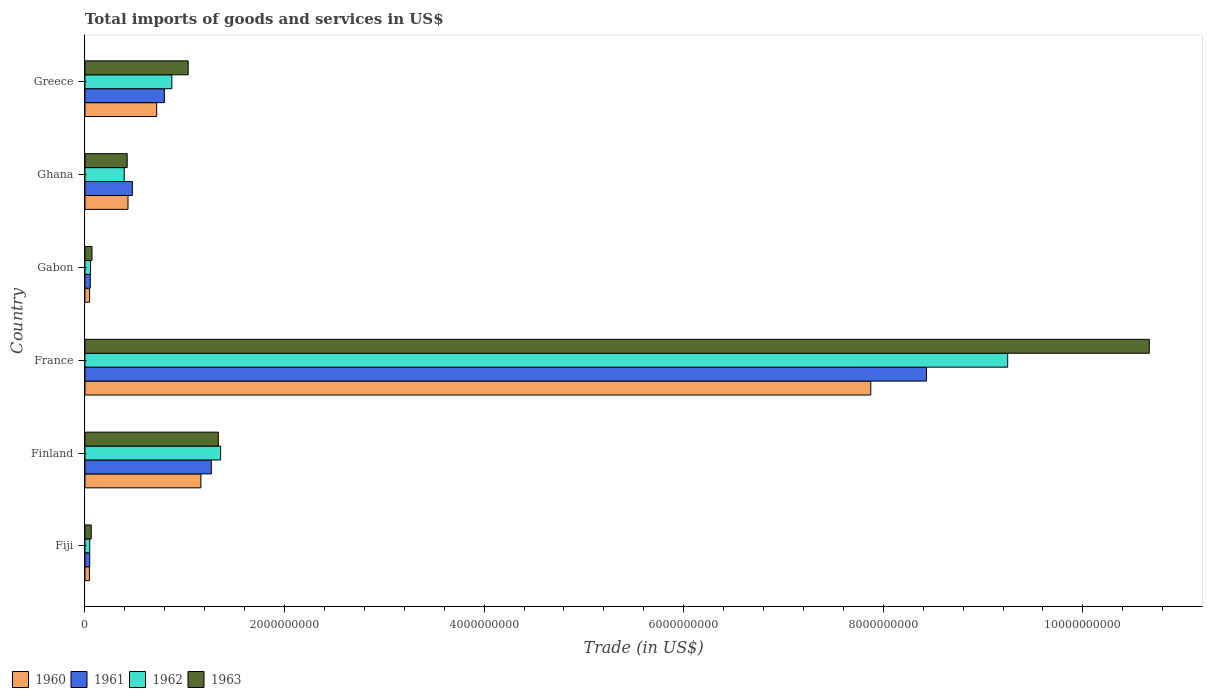How many different coloured bars are there?
Make the answer very short. 4. How many groups of bars are there?
Ensure brevity in your answer.  6. Are the number of bars per tick equal to the number of legend labels?
Your answer should be very brief. Yes. Are the number of bars on each tick of the Y-axis equal?
Offer a very short reply. Yes. How many bars are there on the 4th tick from the top?
Your answer should be compact. 4. What is the label of the 1st group of bars from the top?
Offer a very short reply. Greece. In how many cases, is the number of bars for a given country not equal to the number of legend labels?
Keep it short and to the point. 0. What is the total imports of goods and services in 1963 in Finland?
Provide a succinct answer. 1.34e+09. Across all countries, what is the maximum total imports of goods and services in 1963?
Offer a very short reply. 1.07e+1. Across all countries, what is the minimum total imports of goods and services in 1962?
Your response must be concise. 4.77e+07. In which country was the total imports of goods and services in 1962 minimum?
Provide a succinct answer. Fiji. What is the total total imports of goods and services in 1963 in the graph?
Provide a short and direct response. 1.36e+1. What is the difference between the total imports of goods and services in 1962 in Finland and that in Ghana?
Provide a succinct answer. 9.66e+08. What is the difference between the total imports of goods and services in 1962 in France and the total imports of goods and services in 1963 in Gabon?
Your answer should be compact. 9.18e+09. What is the average total imports of goods and services in 1961 per country?
Keep it short and to the point. 1.85e+09. What is the difference between the total imports of goods and services in 1961 and total imports of goods and services in 1962 in Finland?
Offer a very short reply. -9.31e+07. In how many countries, is the total imports of goods and services in 1962 greater than 2000000000 US$?
Your answer should be very brief. 1. What is the ratio of the total imports of goods and services in 1960 in Finland to that in Gabon?
Your response must be concise. 25.17. What is the difference between the highest and the second highest total imports of goods and services in 1960?
Provide a short and direct response. 6.71e+09. What is the difference between the highest and the lowest total imports of goods and services in 1961?
Your response must be concise. 8.39e+09. What does the 2nd bar from the top in Ghana represents?
Offer a terse response. 1962. Is it the case that in every country, the sum of the total imports of goods and services in 1962 and total imports of goods and services in 1963 is greater than the total imports of goods and services in 1960?
Ensure brevity in your answer.  Yes. Are all the bars in the graph horizontal?
Your answer should be compact. Yes. How many countries are there in the graph?
Provide a short and direct response. 6. What is the difference between two consecutive major ticks on the X-axis?
Your answer should be compact. 2.00e+09. Does the graph contain any zero values?
Provide a succinct answer. No. Does the graph contain grids?
Ensure brevity in your answer.  No. How many legend labels are there?
Provide a short and direct response. 4. How are the legend labels stacked?
Provide a succinct answer. Horizontal. What is the title of the graph?
Provide a short and direct response. Total imports of goods and services in US$. What is the label or title of the X-axis?
Give a very brief answer. Trade (in US$). What is the Trade (in US$) in 1960 in Fiji?
Your answer should be compact. 4.48e+07. What is the Trade (in US$) of 1961 in Fiji?
Offer a very short reply. 4.77e+07. What is the Trade (in US$) in 1962 in Fiji?
Your answer should be compact. 4.77e+07. What is the Trade (in US$) in 1963 in Fiji?
Your response must be concise. 6.30e+07. What is the Trade (in US$) of 1960 in Finland?
Ensure brevity in your answer.  1.16e+09. What is the Trade (in US$) of 1961 in Finland?
Provide a succinct answer. 1.27e+09. What is the Trade (in US$) in 1962 in Finland?
Offer a terse response. 1.36e+09. What is the Trade (in US$) in 1963 in Finland?
Provide a short and direct response. 1.34e+09. What is the Trade (in US$) of 1960 in France?
Make the answer very short. 7.87e+09. What is the Trade (in US$) in 1961 in France?
Give a very brief answer. 8.43e+09. What is the Trade (in US$) in 1962 in France?
Your answer should be compact. 9.25e+09. What is the Trade (in US$) of 1963 in France?
Keep it short and to the point. 1.07e+1. What is the Trade (in US$) in 1960 in Gabon?
Offer a very short reply. 4.62e+07. What is the Trade (in US$) in 1961 in Gabon?
Your response must be concise. 5.31e+07. What is the Trade (in US$) in 1962 in Gabon?
Your answer should be compact. 5.62e+07. What is the Trade (in US$) in 1963 in Gabon?
Offer a terse response. 7.01e+07. What is the Trade (in US$) of 1960 in Ghana?
Offer a very short reply. 4.31e+08. What is the Trade (in US$) of 1961 in Ghana?
Your answer should be compact. 4.75e+08. What is the Trade (in US$) of 1962 in Ghana?
Your response must be concise. 3.94e+08. What is the Trade (in US$) in 1963 in Ghana?
Your answer should be very brief. 4.23e+08. What is the Trade (in US$) of 1960 in Greece?
Give a very brief answer. 7.19e+08. What is the Trade (in US$) of 1961 in Greece?
Your answer should be very brief. 7.96e+08. What is the Trade (in US$) in 1962 in Greece?
Ensure brevity in your answer.  8.70e+08. What is the Trade (in US$) in 1963 in Greece?
Provide a short and direct response. 1.03e+09. Across all countries, what is the maximum Trade (in US$) in 1960?
Your answer should be very brief. 7.87e+09. Across all countries, what is the maximum Trade (in US$) in 1961?
Your answer should be very brief. 8.43e+09. Across all countries, what is the maximum Trade (in US$) in 1962?
Give a very brief answer. 9.25e+09. Across all countries, what is the maximum Trade (in US$) in 1963?
Ensure brevity in your answer.  1.07e+1. Across all countries, what is the minimum Trade (in US$) in 1960?
Offer a very short reply. 4.48e+07. Across all countries, what is the minimum Trade (in US$) of 1961?
Your answer should be very brief. 4.77e+07. Across all countries, what is the minimum Trade (in US$) of 1962?
Ensure brevity in your answer.  4.77e+07. Across all countries, what is the minimum Trade (in US$) of 1963?
Give a very brief answer. 6.30e+07. What is the total Trade (in US$) of 1960 in the graph?
Keep it short and to the point. 1.03e+1. What is the total Trade (in US$) of 1961 in the graph?
Offer a very short reply. 1.11e+1. What is the total Trade (in US$) in 1962 in the graph?
Offer a terse response. 1.20e+1. What is the total Trade (in US$) of 1963 in the graph?
Provide a short and direct response. 1.36e+1. What is the difference between the Trade (in US$) of 1960 in Fiji and that in Finland?
Keep it short and to the point. -1.12e+09. What is the difference between the Trade (in US$) in 1961 in Fiji and that in Finland?
Offer a very short reply. -1.22e+09. What is the difference between the Trade (in US$) in 1962 in Fiji and that in Finland?
Make the answer very short. -1.31e+09. What is the difference between the Trade (in US$) in 1963 in Fiji and that in Finland?
Your response must be concise. -1.27e+09. What is the difference between the Trade (in US$) in 1960 in Fiji and that in France?
Make the answer very short. -7.83e+09. What is the difference between the Trade (in US$) in 1961 in Fiji and that in France?
Make the answer very short. -8.39e+09. What is the difference between the Trade (in US$) of 1962 in Fiji and that in France?
Make the answer very short. -9.20e+09. What is the difference between the Trade (in US$) of 1963 in Fiji and that in France?
Ensure brevity in your answer.  -1.06e+1. What is the difference between the Trade (in US$) of 1960 in Fiji and that in Gabon?
Give a very brief answer. -1.32e+06. What is the difference between the Trade (in US$) of 1961 in Fiji and that in Gabon?
Offer a terse response. -5.35e+06. What is the difference between the Trade (in US$) of 1962 in Fiji and that in Gabon?
Give a very brief answer. -8.51e+06. What is the difference between the Trade (in US$) in 1963 in Fiji and that in Gabon?
Keep it short and to the point. -7.16e+06. What is the difference between the Trade (in US$) in 1960 in Fiji and that in Ghana?
Ensure brevity in your answer.  -3.87e+08. What is the difference between the Trade (in US$) of 1961 in Fiji and that in Ghana?
Ensure brevity in your answer.  -4.27e+08. What is the difference between the Trade (in US$) in 1962 in Fiji and that in Ghana?
Your answer should be compact. -3.46e+08. What is the difference between the Trade (in US$) in 1963 in Fiji and that in Ghana?
Make the answer very short. -3.60e+08. What is the difference between the Trade (in US$) of 1960 in Fiji and that in Greece?
Provide a succinct answer. -6.74e+08. What is the difference between the Trade (in US$) of 1961 in Fiji and that in Greece?
Make the answer very short. -7.48e+08. What is the difference between the Trade (in US$) of 1962 in Fiji and that in Greece?
Keep it short and to the point. -8.23e+08. What is the difference between the Trade (in US$) in 1963 in Fiji and that in Greece?
Offer a very short reply. -9.71e+08. What is the difference between the Trade (in US$) in 1960 in Finland and that in France?
Give a very brief answer. -6.71e+09. What is the difference between the Trade (in US$) of 1961 in Finland and that in France?
Your response must be concise. -7.17e+09. What is the difference between the Trade (in US$) of 1962 in Finland and that in France?
Keep it short and to the point. -7.89e+09. What is the difference between the Trade (in US$) of 1963 in Finland and that in France?
Your answer should be very brief. -9.33e+09. What is the difference between the Trade (in US$) in 1960 in Finland and that in Gabon?
Offer a very short reply. 1.12e+09. What is the difference between the Trade (in US$) of 1961 in Finland and that in Gabon?
Ensure brevity in your answer.  1.21e+09. What is the difference between the Trade (in US$) in 1962 in Finland and that in Gabon?
Make the answer very short. 1.30e+09. What is the difference between the Trade (in US$) in 1963 in Finland and that in Gabon?
Ensure brevity in your answer.  1.27e+09. What is the difference between the Trade (in US$) of 1960 in Finland and that in Ghana?
Provide a short and direct response. 7.30e+08. What is the difference between the Trade (in US$) in 1961 in Finland and that in Ghana?
Keep it short and to the point. 7.91e+08. What is the difference between the Trade (in US$) in 1962 in Finland and that in Ghana?
Offer a terse response. 9.66e+08. What is the difference between the Trade (in US$) of 1963 in Finland and that in Ghana?
Your answer should be very brief. 9.13e+08. What is the difference between the Trade (in US$) in 1960 in Finland and that in Greece?
Provide a succinct answer. 4.43e+08. What is the difference between the Trade (in US$) in 1961 in Finland and that in Greece?
Your answer should be compact. 4.70e+08. What is the difference between the Trade (in US$) in 1962 in Finland and that in Greece?
Offer a terse response. 4.89e+08. What is the difference between the Trade (in US$) in 1963 in Finland and that in Greece?
Provide a succinct answer. 3.02e+08. What is the difference between the Trade (in US$) in 1960 in France and that in Gabon?
Keep it short and to the point. 7.83e+09. What is the difference between the Trade (in US$) of 1961 in France and that in Gabon?
Provide a short and direct response. 8.38e+09. What is the difference between the Trade (in US$) in 1962 in France and that in Gabon?
Provide a short and direct response. 9.19e+09. What is the difference between the Trade (in US$) of 1963 in France and that in Gabon?
Your answer should be compact. 1.06e+1. What is the difference between the Trade (in US$) of 1960 in France and that in Ghana?
Give a very brief answer. 7.44e+09. What is the difference between the Trade (in US$) in 1961 in France and that in Ghana?
Offer a very short reply. 7.96e+09. What is the difference between the Trade (in US$) of 1962 in France and that in Ghana?
Keep it short and to the point. 8.85e+09. What is the difference between the Trade (in US$) in 1963 in France and that in Ghana?
Provide a short and direct response. 1.02e+1. What is the difference between the Trade (in US$) in 1960 in France and that in Greece?
Keep it short and to the point. 7.16e+09. What is the difference between the Trade (in US$) of 1961 in France and that in Greece?
Offer a very short reply. 7.64e+09. What is the difference between the Trade (in US$) in 1962 in France and that in Greece?
Ensure brevity in your answer.  8.38e+09. What is the difference between the Trade (in US$) in 1963 in France and that in Greece?
Offer a very short reply. 9.63e+09. What is the difference between the Trade (in US$) in 1960 in Gabon and that in Ghana?
Provide a succinct answer. -3.85e+08. What is the difference between the Trade (in US$) in 1961 in Gabon and that in Ghana?
Your answer should be compact. -4.22e+08. What is the difference between the Trade (in US$) of 1962 in Gabon and that in Ghana?
Make the answer very short. -3.37e+08. What is the difference between the Trade (in US$) in 1963 in Gabon and that in Ghana?
Your answer should be compact. -3.53e+08. What is the difference between the Trade (in US$) of 1960 in Gabon and that in Greece?
Offer a very short reply. -6.72e+08. What is the difference between the Trade (in US$) in 1961 in Gabon and that in Greece?
Give a very brief answer. -7.43e+08. What is the difference between the Trade (in US$) in 1962 in Gabon and that in Greece?
Provide a short and direct response. -8.14e+08. What is the difference between the Trade (in US$) of 1963 in Gabon and that in Greece?
Keep it short and to the point. -9.64e+08. What is the difference between the Trade (in US$) in 1960 in Ghana and that in Greece?
Offer a terse response. -2.87e+08. What is the difference between the Trade (in US$) in 1961 in Ghana and that in Greece?
Keep it short and to the point. -3.21e+08. What is the difference between the Trade (in US$) of 1962 in Ghana and that in Greece?
Your response must be concise. -4.77e+08. What is the difference between the Trade (in US$) in 1963 in Ghana and that in Greece?
Ensure brevity in your answer.  -6.11e+08. What is the difference between the Trade (in US$) of 1960 in Fiji and the Trade (in US$) of 1961 in Finland?
Make the answer very short. -1.22e+09. What is the difference between the Trade (in US$) of 1960 in Fiji and the Trade (in US$) of 1962 in Finland?
Make the answer very short. -1.31e+09. What is the difference between the Trade (in US$) of 1960 in Fiji and the Trade (in US$) of 1963 in Finland?
Provide a short and direct response. -1.29e+09. What is the difference between the Trade (in US$) of 1961 in Fiji and the Trade (in US$) of 1962 in Finland?
Offer a terse response. -1.31e+09. What is the difference between the Trade (in US$) of 1961 in Fiji and the Trade (in US$) of 1963 in Finland?
Make the answer very short. -1.29e+09. What is the difference between the Trade (in US$) in 1962 in Fiji and the Trade (in US$) in 1963 in Finland?
Make the answer very short. -1.29e+09. What is the difference between the Trade (in US$) of 1960 in Fiji and the Trade (in US$) of 1961 in France?
Provide a succinct answer. -8.39e+09. What is the difference between the Trade (in US$) in 1960 in Fiji and the Trade (in US$) in 1962 in France?
Keep it short and to the point. -9.20e+09. What is the difference between the Trade (in US$) in 1960 in Fiji and the Trade (in US$) in 1963 in France?
Offer a terse response. -1.06e+1. What is the difference between the Trade (in US$) in 1961 in Fiji and the Trade (in US$) in 1962 in France?
Ensure brevity in your answer.  -9.20e+09. What is the difference between the Trade (in US$) in 1961 in Fiji and the Trade (in US$) in 1963 in France?
Offer a terse response. -1.06e+1. What is the difference between the Trade (in US$) in 1962 in Fiji and the Trade (in US$) in 1963 in France?
Ensure brevity in your answer.  -1.06e+1. What is the difference between the Trade (in US$) of 1960 in Fiji and the Trade (in US$) of 1961 in Gabon?
Make the answer very short. -8.25e+06. What is the difference between the Trade (in US$) of 1960 in Fiji and the Trade (in US$) of 1962 in Gabon?
Offer a very short reply. -1.14e+07. What is the difference between the Trade (in US$) in 1960 in Fiji and the Trade (in US$) in 1963 in Gabon?
Make the answer very short. -2.53e+07. What is the difference between the Trade (in US$) in 1961 in Fiji and the Trade (in US$) in 1962 in Gabon?
Give a very brief answer. -8.51e+06. What is the difference between the Trade (in US$) of 1961 in Fiji and the Trade (in US$) of 1963 in Gabon?
Your answer should be very brief. -2.24e+07. What is the difference between the Trade (in US$) in 1962 in Fiji and the Trade (in US$) in 1963 in Gabon?
Your response must be concise. -2.24e+07. What is the difference between the Trade (in US$) in 1960 in Fiji and the Trade (in US$) in 1961 in Ghana?
Give a very brief answer. -4.30e+08. What is the difference between the Trade (in US$) in 1960 in Fiji and the Trade (in US$) in 1962 in Ghana?
Your answer should be very brief. -3.49e+08. What is the difference between the Trade (in US$) in 1960 in Fiji and the Trade (in US$) in 1963 in Ghana?
Keep it short and to the point. -3.78e+08. What is the difference between the Trade (in US$) of 1961 in Fiji and the Trade (in US$) of 1962 in Ghana?
Your answer should be very brief. -3.46e+08. What is the difference between the Trade (in US$) of 1961 in Fiji and the Trade (in US$) of 1963 in Ghana?
Keep it short and to the point. -3.75e+08. What is the difference between the Trade (in US$) in 1962 in Fiji and the Trade (in US$) in 1963 in Ghana?
Offer a very short reply. -3.75e+08. What is the difference between the Trade (in US$) of 1960 in Fiji and the Trade (in US$) of 1961 in Greece?
Keep it short and to the point. -7.51e+08. What is the difference between the Trade (in US$) of 1960 in Fiji and the Trade (in US$) of 1962 in Greece?
Give a very brief answer. -8.25e+08. What is the difference between the Trade (in US$) in 1960 in Fiji and the Trade (in US$) in 1963 in Greece?
Keep it short and to the point. -9.89e+08. What is the difference between the Trade (in US$) in 1961 in Fiji and the Trade (in US$) in 1962 in Greece?
Provide a short and direct response. -8.23e+08. What is the difference between the Trade (in US$) of 1961 in Fiji and the Trade (in US$) of 1963 in Greece?
Make the answer very short. -9.86e+08. What is the difference between the Trade (in US$) of 1962 in Fiji and the Trade (in US$) of 1963 in Greece?
Give a very brief answer. -9.86e+08. What is the difference between the Trade (in US$) of 1960 in Finland and the Trade (in US$) of 1961 in France?
Your response must be concise. -7.27e+09. What is the difference between the Trade (in US$) of 1960 in Finland and the Trade (in US$) of 1962 in France?
Keep it short and to the point. -8.08e+09. What is the difference between the Trade (in US$) of 1960 in Finland and the Trade (in US$) of 1963 in France?
Keep it short and to the point. -9.50e+09. What is the difference between the Trade (in US$) in 1961 in Finland and the Trade (in US$) in 1962 in France?
Your response must be concise. -7.98e+09. What is the difference between the Trade (in US$) in 1961 in Finland and the Trade (in US$) in 1963 in France?
Keep it short and to the point. -9.40e+09. What is the difference between the Trade (in US$) of 1962 in Finland and the Trade (in US$) of 1963 in France?
Your answer should be very brief. -9.31e+09. What is the difference between the Trade (in US$) of 1960 in Finland and the Trade (in US$) of 1961 in Gabon?
Keep it short and to the point. 1.11e+09. What is the difference between the Trade (in US$) in 1960 in Finland and the Trade (in US$) in 1962 in Gabon?
Your answer should be compact. 1.11e+09. What is the difference between the Trade (in US$) of 1960 in Finland and the Trade (in US$) of 1963 in Gabon?
Make the answer very short. 1.09e+09. What is the difference between the Trade (in US$) of 1961 in Finland and the Trade (in US$) of 1962 in Gabon?
Offer a terse response. 1.21e+09. What is the difference between the Trade (in US$) in 1961 in Finland and the Trade (in US$) in 1963 in Gabon?
Provide a succinct answer. 1.20e+09. What is the difference between the Trade (in US$) in 1962 in Finland and the Trade (in US$) in 1963 in Gabon?
Give a very brief answer. 1.29e+09. What is the difference between the Trade (in US$) in 1960 in Finland and the Trade (in US$) in 1961 in Ghana?
Make the answer very short. 6.87e+08. What is the difference between the Trade (in US$) in 1960 in Finland and the Trade (in US$) in 1962 in Ghana?
Make the answer very short. 7.68e+08. What is the difference between the Trade (in US$) in 1960 in Finland and the Trade (in US$) in 1963 in Ghana?
Provide a short and direct response. 7.39e+08. What is the difference between the Trade (in US$) in 1961 in Finland and the Trade (in US$) in 1962 in Ghana?
Offer a terse response. 8.73e+08. What is the difference between the Trade (in US$) of 1961 in Finland and the Trade (in US$) of 1963 in Ghana?
Provide a succinct answer. 8.43e+08. What is the difference between the Trade (in US$) of 1962 in Finland and the Trade (in US$) of 1963 in Ghana?
Offer a terse response. 9.36e+08. What is the difference between the Trade (in US$) of 1960 in Finland and the Trade (in US$) of 1961 in Greece?
Your response must be concise. 3.66e+08. What is the difference between the Trade (in US$) in 1960 in Finland and the Trade (in US$) in 1962 in Greece?
Offer a very short reply. 2.92e+08. What is the difference between the Trade (in US$) in 1960 in Finland and the Trade (in US$) in 1963 in Greece?
Your response must be concise. 1.28e+08. What is the difference between the Trade (in US$) of 1961 in Finland and the Trade (in US$) of 1962 in Greece?
Offer a very short reply. 3.96e+08. What is the difference between the Trade (in US$) of 1961 in Finland and the Trade (in US$) of 1963 in Greece?
Ensure brevity in your answer.  2.32e+08. What is the difference between the Trade (in US$) in 1962 in Finland and the Trade (in US$) in 1963 in Greece?
Offer a very short reply. 3.25e+08. What is the difference between the Trade (in US$) in 1960 in France and the Trade (in US$) in 1961 in Gabon?
Provide a short and direct response. 7.82e+09. What is the difference between the Trade (in US$) of 1960 in France and the Trade (in US$) of 1962 in Gabon?
Keep it short and to the point. 7.82e+09. What is the difference between the Trade (in US$) in 1960 in France and the Trade (in US$) in 1963 in Gabon?
Offer a very short reply. 7.80e+09. What is the difference between the Trade (in US$) in 1961 in France and the Trade (in US$) in 1962 in Gabon?
Provide a short and direct response. 8.38e+09. What is the difference between the Trade (in US$) of 1961 in France and the Trade (in US$) of 1963 in Gabon?
Offer a very short reply. 8.36e+09. What is the difference between the Trade (in US$) of 1962 in France and the Trade (in US$) of 1963 in Gabon?
Your answer should be very brief. 9.18e+09. What is the difference between the Trade (in US$) in 1960 in France and the Trade (in US$) in 1961 in Ghana?
Ensure brevity in your answer.  7.40e+09. What is the difference between the Trade (in US$) in 1960 in France and the Trade (in US$) in 1962 in Ghana?
Your answer should be compact. 7.48e+09. What is the difference between the Trade (in US$) of 1960 in France and the Trade (in US$) of 1963 in Ghana?
Your response must be concise. 7.45e+09. What is the difference between the Trade (in US$) in 1961 in France and the Trade (in US$) in 1962 in Ghana?
Offer a very short reply. 8.04e+09. What is the difference between the Trade (in US$) of 1961 in France and the Trade (in US$) of 1963 in Ghana?
Offer a terse response. 8.01e+09. What is the difference between the Trade (in US$) of 1962 in France and the Trade (in US$) of 1963 in Ghana?
Your response must be concise. 8.82e+09. What is the difference between the Trade (in US$) of 1960 in France and the Trade (in US$) of 1961 in Greece?
Keep it short and to the point. 7.08e+09. What is the difference between the Trade (in US$) in 1960 in France and the Trade (in US$) in 1962 in Greece?
Offer a very short reply. 7.00e+09. What is the difference between the Trade (in US$) of 1960 in France and the Trade (in US$) of 1963 in Greece?
Make the answer very short. 6.84e+09. What is the difference between the Trade (in US$) of 1961 in France and the Trade (in US$) of 1962 in Greece?
Keep it short and to the point. 7.56e+09. What is the difference between the Trade (in US$) of 1961 in France and the Trade (in US$) of 1963 in Greece?
Your answer should be compact. 7.40e+09. What is the difference between the Trade (in US$) of 1962 in France and the Trade (in US$) of 1963 in Greece?
Make the answer very short. 8.21e+09. What is the difference between the Trade (in US$) in 1960 in Gabon and the Trade (in US$) in 1961 in Ghana?
Provide a short and direct response. -4.29e+08. What is the difference between the Trade (in US$) in 1960 in Gabon and the Trade (in US$) in 1962 in Ghana?
Your answer should be very brief. -3.47e+08. What is the difference between the Trade (in US$) in 1960 in Gabon and the Trade (in US$) in 1963 in Ghana?
Offer a terse response. -3.77e+08. What is the difference between the Trade (in US$) of 1961 in Gabon and the Trade (in US$) of 1962 in Ghana?
Offer a very short reply. -3.41e+08. What is the difference between the Trade (in US$) in 1961 in Gabon and the Trade (in US$) in 1963 in Ghana?
Give a very brief answer. -3.70e+08. What is the difference between the Trade (in US$) in 1962 in Gabon and the Trade (in US$) in 1963 in Ghana?
Ensure brevity in your answer.  -3.67e+08. What is the difference between the Trade (in US$) of 1960 in Gabon and the Trade (in US$) of 1961 in Greece?
Provide a short and direct response. -7.50e+08. What is the difference between the Trade (in US$) in 1960 in Gabon and the Trade (in US$) in 1962 in Greece?
Give a very brief answer. -8.24e+08. What is the difference between the Trade (in US$) of 1960 in Gabon and the Trade (in US$) of 1963 in Greece?
Ensure brevity in your answer.  -9.88e+08. What is the difference between the Trade (in US$) in 1961 in Gabon and the Trade (in US$) in 1962 in Greece?
Your answer should be very brief. -8.17e+08. What is the difference between the Trade (in US$) in 1961 in Gabon and the Trade (in US$) in 1963 in Greece?
Your answer should be compact. -9.81e+08. What is the difference between the Trade (in US$) of 1962 in Gabon and the Trade (in US$) of 1963 in Greece?
Offer a very short reply. -9.78e+08. What is the difference between the Trade (in US$) in 1960 in Ghana and the Trade (in US$) in 1961 in Greece?
Keep it short and to the point. -3.64e+08. What is the difference between the Trade (in US$) in 1960 in Ghana and the Trade (in US$) in 1962 in Greece?
Provide a succinct answer. -4.39e+08. What is the difference between the Trade (in US$) in 1960 in Ghana and the Trade (in US$) in 1963 in Greece?
Your response must be concise. -6.03e+08. What is the difference between the Trade (in US$) of 1961 in Ghana and the Trade (in US$) of 1962 in Greece?
Make the answer very short. -3.95e+08. What is the difference between the Trade (in US$) in 1961 in Ghana and the Trade (in US$) in 1963 in Greece?
Offer a very short reply. -5.59e+08. What is the difference between the Trade (in US$) of 1962 in Ghana and the Trade (in US$) of 1963 in Greece?
Make the answer very short. -6.41e+08. What is the average Trade (in US$) in 1960 per country?
Keep it short and to the point. 1.71e+09. What is the average Trade (in US$) in 1961 per country?
Offer a terse response. 1.85e+09. What is the average Trade (in US$) in 1962 per country?
Offer a terse response. 2.00e+09. What is the average Trade (in US$) in 1963 per country?
Provide a succinct answer. 2.27e+09. What is the difference between the Trade (in US$) in 1960 and Trade (in US$) in 1961 in Fiji?
Your response must be concise. -2.90e+06. What is the difference between the Trade (in US$) in 1960 and Trade (in US$) in 1962 in Fiji?
Your answer should be very brief. -2.90e+06. What is the difference between the Trade (in US$) in 1960 and Trade (in US$) in 1963 in Fiji?
Your response must be concise. -1.81e+07. What is the difference between the Trade (in US$) of 1961 and Trade (in US$) of 1963 in Fiji?
Offer a very short reply. -1.52e+07. What is the difference between the Trade (in US$) in 1962 and Trade (in US$) in 1963 in Fiji?
Ensure brevity in your answer.  -1.52e+07. What is the difference between the Trade (in US$) of 1960 and Trade (in US$) of 1961 in Finland?
Your response must be concise. -1.04e+08. What is the difference between the Trade (in US$) in 1960 and Trade (in US$) in 1962 in Finland?
Keep it short and to the point. -1.97e+08. What is the difference between the Trade (in US$) of 1960 and Trade (in US$) of 1963 in Finland?
Offer a terse response. -1.75e+08. What is the difference between the Trade (in US$) in 1961 and Trade (in US$) in 1962 in Finland?
Keep it short and to the point. -9.31e+07. What is the difference between the Trade (in US$) in 1961 and Trade (in US$) in 1963 in Finland?
Make the answer very short. -7.02e+07. What is the difference between the Trade (in US$) in 1962 and Trade (in US$) in 1963 in Finland?
Provide a short and direct response. 2.29e+07. What is the difference between the Trade (in US$) in 1960 and Trade (in US$) in 1961 in France?
Give a very brief answer. -5.58e+08. What is the difference between the Trade (in US$) in 1960 and Trade (in US$) in 1962 in France?
Keep it short and to the point. -1.37e+09. What is the difference between the Trade (in US$) in 1960 and Trade (in US$) in 1963 in France?
Your response must be concise. -2.79e+09. What is the difference between the Trade (in US$) in 1961 and Trade (in US$) in 1962 in France?
Give a very brief answer. -8.14e+08. What is the difference between the Trade (in US$) in 1961 and Trade (in US$) in 1963 in France?
Provide a succinct answer. -2.23e+09. What is the difference between the Trade (in US$) of 1962 and Trade (in US$) of 1963 in France?
Provide a short and direct response. -1.42e+09. What is the difference between the Trade (in US$) of 1960 and Trade (in US$) of 1961 in Gabon?
Your answer should be compact. -6.92e+06. What is the difference between the Trade (in US$) of 1960 and Trade (in US$) of 1962 in Gabon?
Provide a succinct answer. -1.01e+07. What is the difference between the Trade (in US$) in 1960 and Trade (in US$) in 1963 in Gabon?
Provide a succinct answer. -2.40e+07. What is the difference between the Trade (in US$) in 1961 and Trade (in US$) in 1962 in Gabon?
Offer a very short reply. -3.16e+06. What is the difference between the Trade (in US$) in 1961 and Trade (in US$) in 1963 in Gabon?
Your answer should be very brief. -1.70e+07. What is the difference between the Trade (in US$) of 1962 and Trade (in US$) of 1963 in Gabon?
Provide a succinct answer. -1.39e+07. What is the difference between the Trade (in US$) in 1960 and Trade (in US$) in 1961 in Ghana?
Keep it short and to the point. -4.34e+07. What is the difference between the Trade (in US$) of 1960 and Trade (in US$) of 1962 in Ghana?
Ensure brevity in your answer.  3.78e+07. What is the difference between the Trade (in US$) in 1960 and Trade (in US$) in 1963 in Ghana?
Your answer should be very brief. 8.40e+06. What is the difference between the Trade (in US$) of 1961 and Trade (in US$) of 1962 in Ghana?
Your response must be concise. 8.12e+07. What is the difference between the Trade (in US$) in 1961 and Trade (in US$) in 1963 in Ghana?
Your answer should be very brief. 5.18e+07. What is the difference between the Trade (in US$) in 1962 and Trade (in US$) in 1963 in Ghana?
Keep it short and to the point. -2.94e+07. What is the difference between the Trade (in US$) of 1960 and Trade (in US$) of 1961 in Greece?
Offer a terse response. -7.72e+07. What is the difference between the Trade (in US$) in 1960 and Trade (in US$) in 1962 in Greece?
Offer a terse response. -1.52e+08. What is the difference between the Trade (in US$) of 1960 and Trade (in US$) of 1963 in Greece?
Offer a very short reply. -3.16e+08. What is the difference between the Trade (in US$) of 1961 and Trade (in US$) of 1962 in Greece?
Ensure brevity in your answer.  -7.45e+07. What is the difference between the Trade (in US$) in 1961 and Trade (in US$) in 1963 in Greece?
Your response must be concise. -2.38e+08. What is the difference between the Trade (in US$) in 1962 and Trade (in US$) in 1963 in Greece?
Your answer should be compact. -1.64e+08. What is the ratio of the Trade (in US$) of 1960 in Fiji to that in Finland?
Your answer should be very brief. 0.04. What is the ratio of the Trade (in US$) in 1961 in Fiji to that in Finland?
Give a very brief answer. 0.04. What is the ratio of the Trade (in US$) of 1962 in Fiji to that in Finland?
Your response must be concise. 0.04. What is the ratio of the Trade (in US$) of 1963 in Fiji to that in Finland?
Keep it short and to the point. 0.05. What is the ratio of the Trade (in US$) of 1960 in Fiji to that in France?
Your answer should be compact. 0.01. What is the ratio of the Trade (in US$) in 1961 in Fiji to that in France?
Give a very brief answer. 0.01. What is the ratio of the Trade (in US$) in 1962 in Fiji to that in France?
Ensure brevity in your answer.  0.01. What is the ratio of the Trade (in US$) of 1963 in Fiji to that in France?
Your answer should be very brief. 0.01. What is the ratio of the Trade (in US$) in 1960 in Fiji to that in Gabon?
Make the answer very short. 0.97. What is the ratio of the Trade (in US$) of 1961 in Fiji to that in Gabon?
Your answer should be very brief. 0.9. What is the ratio of the Trade (in US$) in 1962 in Fiji to that in Gabon?
Your response must be concise. 0.85. What is the ratio of the Trade (in US$) in 1963 in Fiji to that in Gabon?
Provide a short and direct response. 0.9. What is the ratio of the Trade (in US$) of 1960 in Fiji to that in Ghana?
Ensure brevity in your answer.  0.1. What is the ratio of the Trade (in US$) in 1961 in Fiji to that in Ghana?
Provide a short and direct response. 0.1. What is the ratio of the Trade (in US$) of 1962 in Fiji to that in Ghana?
Provide a short and direct response. 0.12. What is the ratio of the Trade (in US$) in 1963 in Fiji to that in Ghana?
Ensure brevity in your answer.  0.15. What is the ratio of the Trade (in US$) of 1960 in Fiji to that in Greece?
Give a very brief answer. 0.06. What is the ratio of the Trade (in US$) of 1961 in Fiji to that in Greece?
Offer a very short reply. 0.06. What is the ratio of the Trade (in US$) in 1962 in Fiji to that in Greece?
Your answer should be very brief. 0.05. What is the ratio of the Trade (in US$) of 1963 in Fiji to that in Greece?
Ensure brevity in your answer.  0.06. What is the ratio of the Trade (in US$) in 1960 in Finland to that in France?
Give a very brief answer. 0.15. What is the ratio of the Trade (in US$) of 1961 in Finland to that in France?
Make the answer very short. 0.15. What is the ratio of the Trade (in US$) of 1962 in Finland to that in France?
Your answer should be compact. 0.15. What is the ratio of the Trade (in US$) of 1963 in Finland to that in France?
Offer a very short reply. 0.13. What is the ratio of the Trade (in US$) of 1960 in Finland to that in Gabon?
Make the answer very short. 25.17. What is the ratio of the Trade (in US$) in 1961 in Finland to that in Gabon?
Provide a short and direct response. 23.85. What is the ratio of the Trade (in US$) in 1962 in Finland to that in Gabon?
Your answer should be very brief. 24.17. What is the ratio of the Trade (in US$) in 1963 in Finland to that in Gabon?
Your response must be concise. 19.06. What is the ratio of the Trade (in US$) of 1960 in Finland to that in Ghana?
Offer a terse response. 2.69. What is the ratio of the Trade (in US$) in 1961 in Finland to that in Ghana?
Offer a terse response. 2.67. What is the ratio of the Trade (in US$) of 1962 in Finland to that in Ghana?
Offer a terse response. 3.45. What is the ratio of the Trade (in US$) of 1963 in Finland to that in Ghana?
Provide a short and direct response. 3.16. What is the ratio of the Trade (in US$) in 1960 in Finland to that in Greece?
Make the answer very short. 1.62. What is the ratio of the Trade (in US$) of 1961 in Finland to that in Greece?
Make the answer very short. 1.59. What is the ratio of the Trade (in US$) in 1962 in Finland to that in Greece?
Offer a terse response. 1.56. What is the ratio of the Trade (in US$) of 1963 in Finland to that in Greece?
Make the answer very short. 1.29. What is the ratio of the Trade (in US$) of 1960 in France to that in Gabon?
Provide a short and direct response. 170.61. What is the ratio of the Trade (in US$) in 1961 in France to that in Gabon?
Provide a succinct answer. 158.88. What is the ratio of the Trade (in US$) in 1962 in France to that in Gabon?
Offer a very short reply. 164.41. What is the ratio of the Trade (in US$) of 1963 in France to that in Gabon?
Your response must be concise. 152.1. What is the ratio of the Trade (in US$) of 1960 in France to that in Ghana?
Offer a very short reply. 18.25. What is the ratio of the Trade (in US$) in 1961 in France to that in Ghana?
Make the answer very short. 17.76. What is the ratio of the Trade (in US$) in 1962 in France to that in Ghana?
Offer a terse response. 23.49. What is the ratio of the Trade (in US$) of 1963 in France to that in Ghana?
Ensure brevity in your answer.  25.21. What is the ratio of the Trade (in US$) of 1960 in France to that in Greece?
Provide a succinct answer. 10.96. What is the ratio of the Trade (in US$) of 1961 in France to that in Greece?
Keep it short and to the point. 10.6. What is the ratio of the Trade (in US$) in 1962 in France to that in Greece?
Keep it short and to the point. 10.63. What is the ratio of the Trade (in US$) in 1963 in France to that in Greece?
Provide a succinct answer. 10.31. What is the ratio of the Trade (in US$) in 1960 in Gabon to that in Ghana?
Provide a succinct answer. 0.11. What is the ratio of the Trade (in US$) of 1961 in Gabon to that in Ghana?
Offer a very short reply. 0.11. What is the ratio of the Trade (in US$) in 1962 in Gabon to that in Ghana?
Offer a terse response. 0.14. What is the ratio of the Trade (in US$) of 1963 in Gabon to that in Ghana?
Your answer should be very brief. 0.17. What is the ratio of the Trade (in US$) of 1960 in Gabon to that in Greece?
Ensure brevity in your answer.  0.06. What is the ratio of the Trade (in US$) of 1961 in Gabon to that in Greece?
Offer a terse response. 0.07. What is the ratio of the Trade (in US$) of 1962 in Gabon to that in Greece?
Give a very brief answer. 0.06. What is the ratio of the Trade (in US$) in 1963 in Gabon to that in Greece?
Offer a very short reply. 0.07. What is the ratio of the Trade (in US$) of 1960 in Ghana to that in Greece?
Provide a short and direct response. 0.6. What is the ratio of the Trade (in US$) in 1961 in Ghana to that in Greece?
Give a very brief answer. 0.6. What is the ratio of the Trade (in US$) in 1962 in Ghana to that in Greece?
Make the answer very short. 0.45. What is the ratio of the Trade (in US$) of 1963 in Ghana to that in Greece?
Provide a succinct answer. 0.41. What is the difference between the highest and the second highest Trade (in US$) of 1960?
Offer a very short reply. 6.71e+09. What is the difference between the highest and the second highest Trade (in US$) of 1961?
Provide a succinct answer. 7.17e+09. What is the difference between the highest and the second highest Trade (in US$) of 1962?
Your response must be concise. 7.89e+09. What is the difference between the highest and the second highest Trade (in US$) of 1963?
Keep it short and to the point. 9.33e+09. What is the difference between the highest and the lowest Trade (in US$) in 1960?
Your response must be concise. 7.83e+09. What is the difference between the highest and the lowest Trade (in US$) of 1961?
Your response must be concise. 8.39e+09. What is the difference between the highest and the lowest Trade (in US$) in 1962?
Offer a terse response. 9.20e+09. What is the difference between the highest and the lowest Trade (in US$) of 1963?
Make the answer very short. 1.06e+1. 